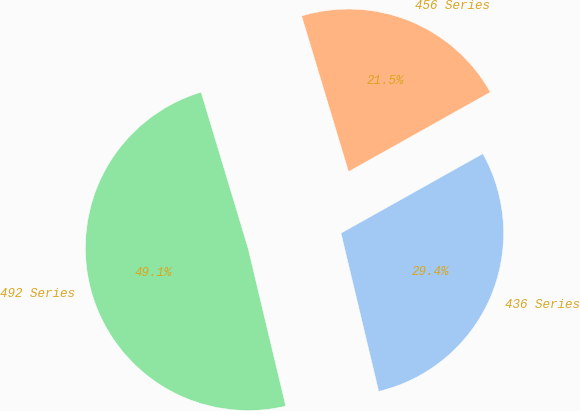Convert chart. <chart><loc_0><loc_0><loc_500><loc_500><pie_chart><fcel>436 Series<fcel>456 Series<fcel>492 Series<nl><fcel>29.4%<fcel>21.53%<fcel>49.07%<nl></chart> 